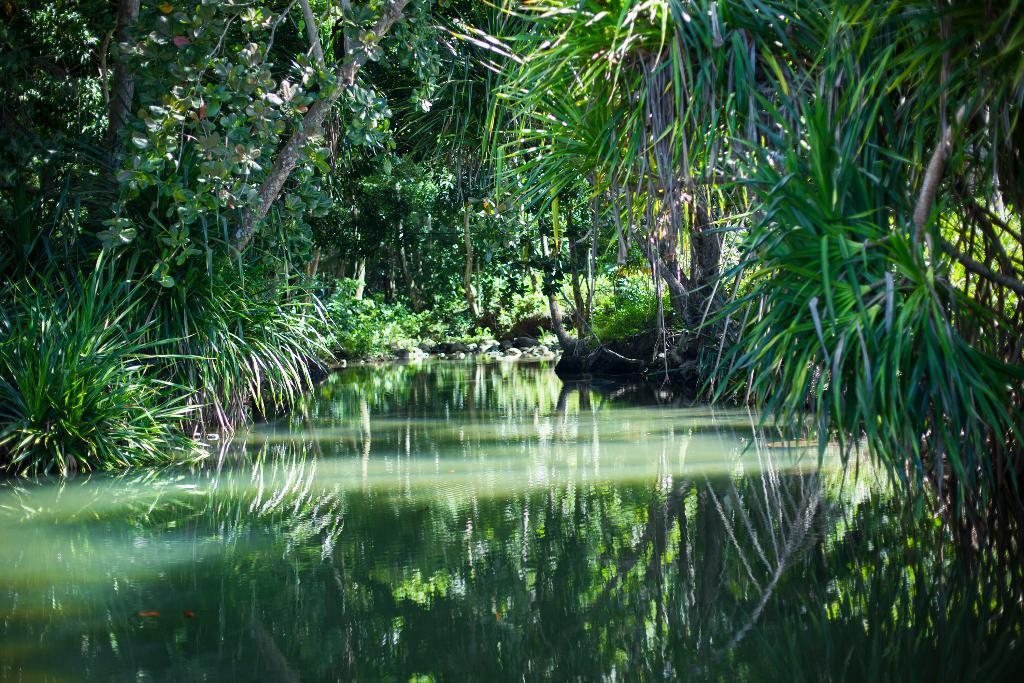What type of natural environment is depicted in the image? The image contains many trees and plants, indicating a natural environment. Can you describe the water visible in the image? Yes, there is water visible in the image. What can be observed in the reflection of the water? The reflection of trees and plants can be seen in the water. What type of transport can be seen in the image? There is no transport visible in the image; it primarily features trees, plants, and water. Is there a church present in the image? No, there is no church present in the image. 